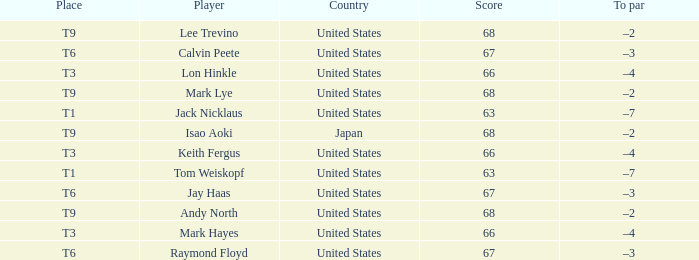Considering the place as t6 and the player as raymond floyd, which country is associated with this context? United States. 